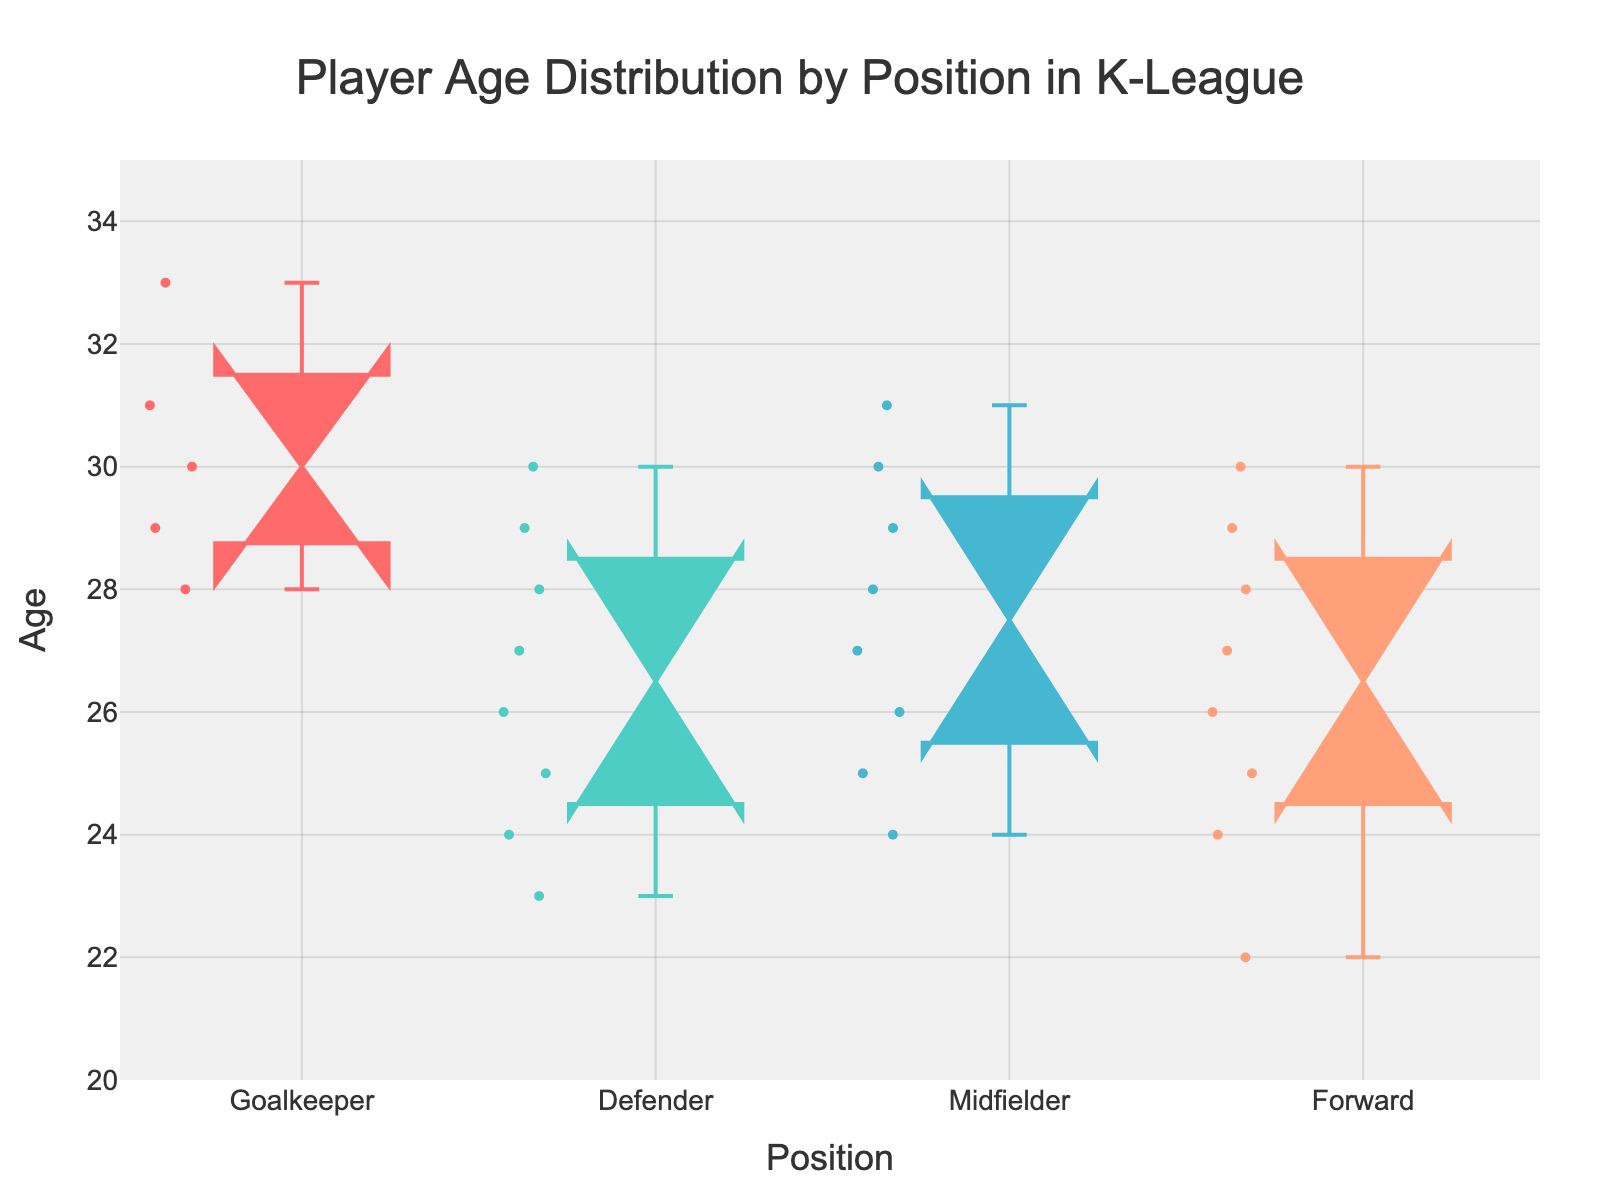what does the title of the figure say? The title of the figure is usually located at the top and provides a summary of what the figure is about. In this case, it reads: 'Player Age Distribution by Position in K-League'.
Answer: Player Age Distribution by Position in K-League what is the youngest age among forwards? To find the youngest age among forwards, look at the lowest point in the forward's notched box plot. The lowest age appears to be 22.
Answer: 22 which position has the highest median age? To determine which position has the highest median age, observe the center line inside each box. The Goalkeeper position has the highest median, which is around 30.
Answer: Goalkeeper what is the range of ages for defenders? The range of ages for defenders can be found by identifying the minimum and maximum data points for the defender's box plot. The minimum is 23 and the maximum is 30, giving a range of 30 - 23 = 7.
Answer: 7 is the age distribution for midfielders wider than for forwards? To determine if the age distribution for midfielders is wider than for forwards, compare the spread (interquartile range and the whiskers) of both box plots. Midfielders have a slightly wider distribution, as their ages range from 24 to 31, while forwards range from 22 to 30.
Answer: Yes which position has the most outliers? To find the position with the most outliers, look for points that fall outside the whiskers of each box plot. The Goalkeeper position has the most outliers, evident by the multiple points outside the whiskers.
Answer: Goalkeeper do all positions have overlapping notches? Notches represent the confidence interval around the median. If notches do not overlap, it suggests a significant difference in medians. Observing the figure, some notches do not overlap, indicating significant differences, especially between Goalkeepers and other positions.
Answer: No what is the median age for forwards? The median age is indicated by the line inside the box portion of the box plot. For forwards, this line is around 27.
Answer: 27 are midfielders typically older or younger than defenders? By comparing the median lines inside the box plots for midfielders and defenders, midfielders are typically older as their median is higher.
Answer: Older 